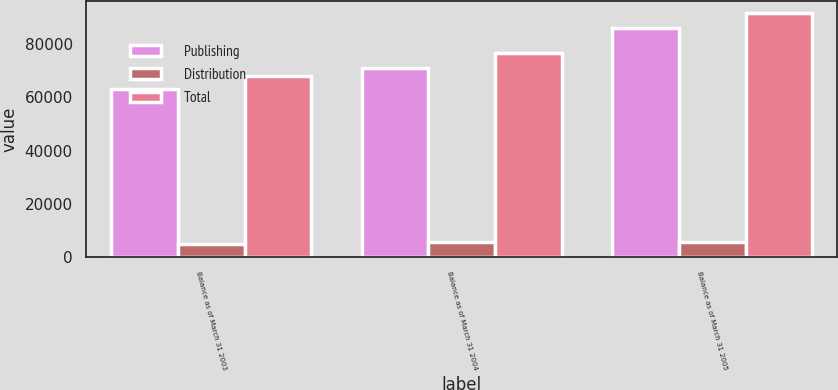Convert chart to OTSL. <chart><loc_0><loc_0><loc_500><loc_500><stacked_bar_chart><ecel><fcel>Balance as of March 31 2003<fcel>Balance as of March 31 2004<fcel>Balance as of March 31 2005<nl><fcel>Publishing<fcel>63194<fcel>70898<fcel>85899<nl><fcel>Distribution<fcel>4825<fcel>5595<fcel>5762<nl><fcel>Total<fcel>68019<fcel>76493<fcel>91661<nl></chart> 